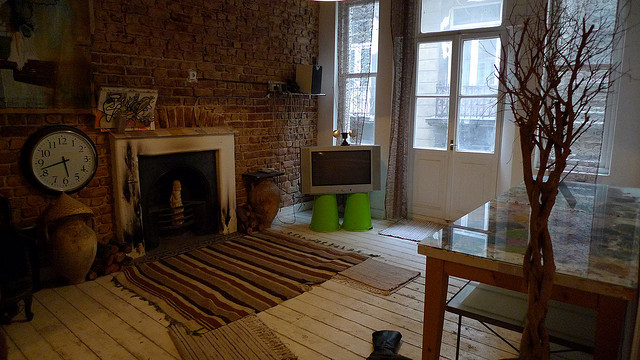How many clocks do you see? 1 